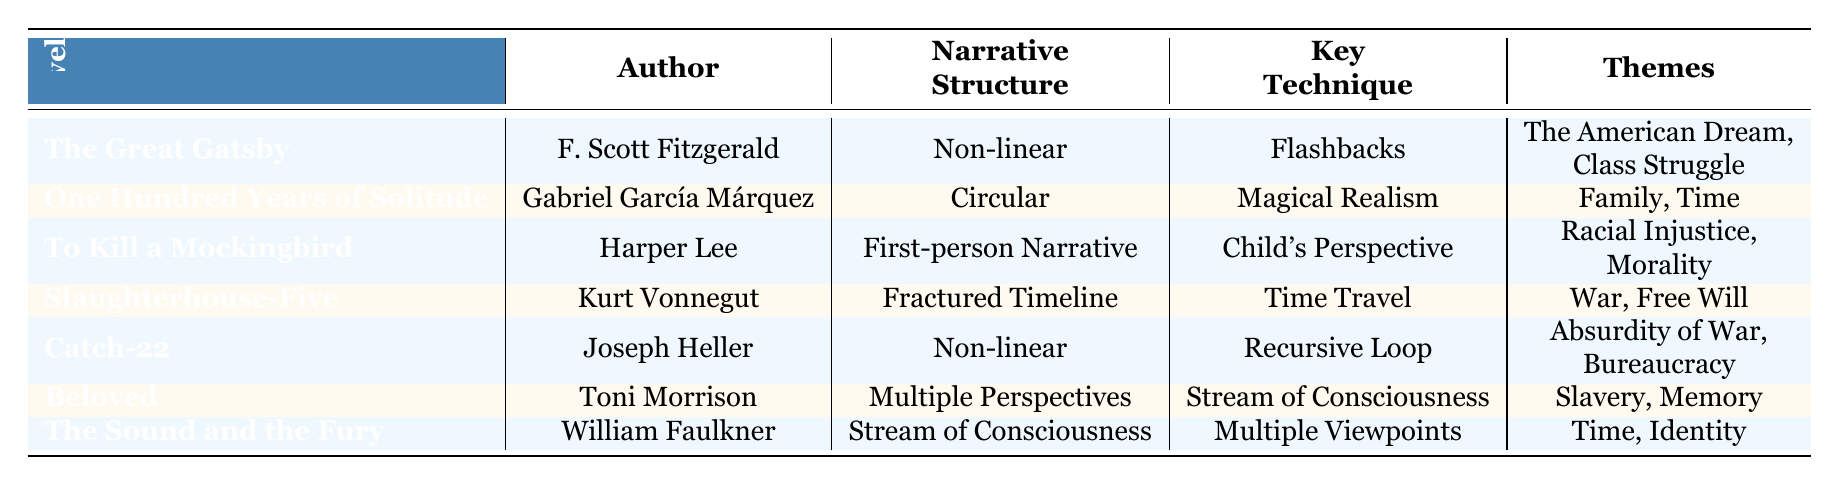What is the narrative structure of "Beloved"? The table specifies that "Beloved" has a narrative structure categorized as "Multiple Perspectives."
Answer: Multiple Perspectives Which author wrote "Catch-22"? The table lists Joseph Heller as the author of "Catch-22."
Answer: Joseph Heller True or False: "The Sound and the Fury" uses a non-linear narrative structure. The information in the table shows that "The Sound and the Fury" uses a "Stream of Consciousness" narrative structure, which is not considered non-linear.
Answer: False What key technique is used in "One Hundred Years of Solitude"? Based on the table, "One Hundred Years of Solitude" employs "Magical Realism" as its key technique.
Answer: Magical Realism How many novels in the table have a theme related to "Memory"? The table indicates that "Beloved" is the only novel that has "Memory" listed as a theme. Thus, the count is one.
Answer: 1 What are the two themes from "Slaughterhouse-Five"? According to the table, the themes associated with "Slaughterhouse-Five" are "War" and "Free Will."
Answer: War, Free Will Which narrative structure patterns use the technique of "Flashbacks"? From the table, the only novel utilizing "Flashbacks" as a key technique is "The Great Gatsby," indicating a non-linear narrative structure.
Answer: The Great Gatsby List the themes of "To Kill a Mockingbird." The table shows that the themes of "To Kill a Mockingbird" are "Racial Injustice" and "Morality."
Answer: Racial Injustice, Morality What is the average number of themes represented in the novels listed? The novels collectively have 13 themes when counted individually, and there are 7 novels. To find the average, divide 13 by 7 (approximately 1.86). Since themes are typically whole units, we can round.
Answer: 2 